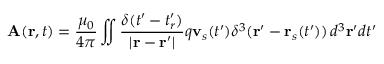<formula> <loc_0><loc_0><loc_500><loc_500>A ( r , t ) = { \frac { \mu _ { 0 } } { 4 \pi } } \iint { \frac { \delta ( t ^ { \prime } - t _ { r } ^ { \prime } ) } { | r - r ^ { \prime } | } } q v _ { s } ( t ^ { \prime } ) \delta ^ { 3 } ( r ^ { \prime } - r _ { s } ( t ^ { \prime } ) ) \, d ^ { 3 } r ^ { \prime } d t ^ { \prime }</formula> 